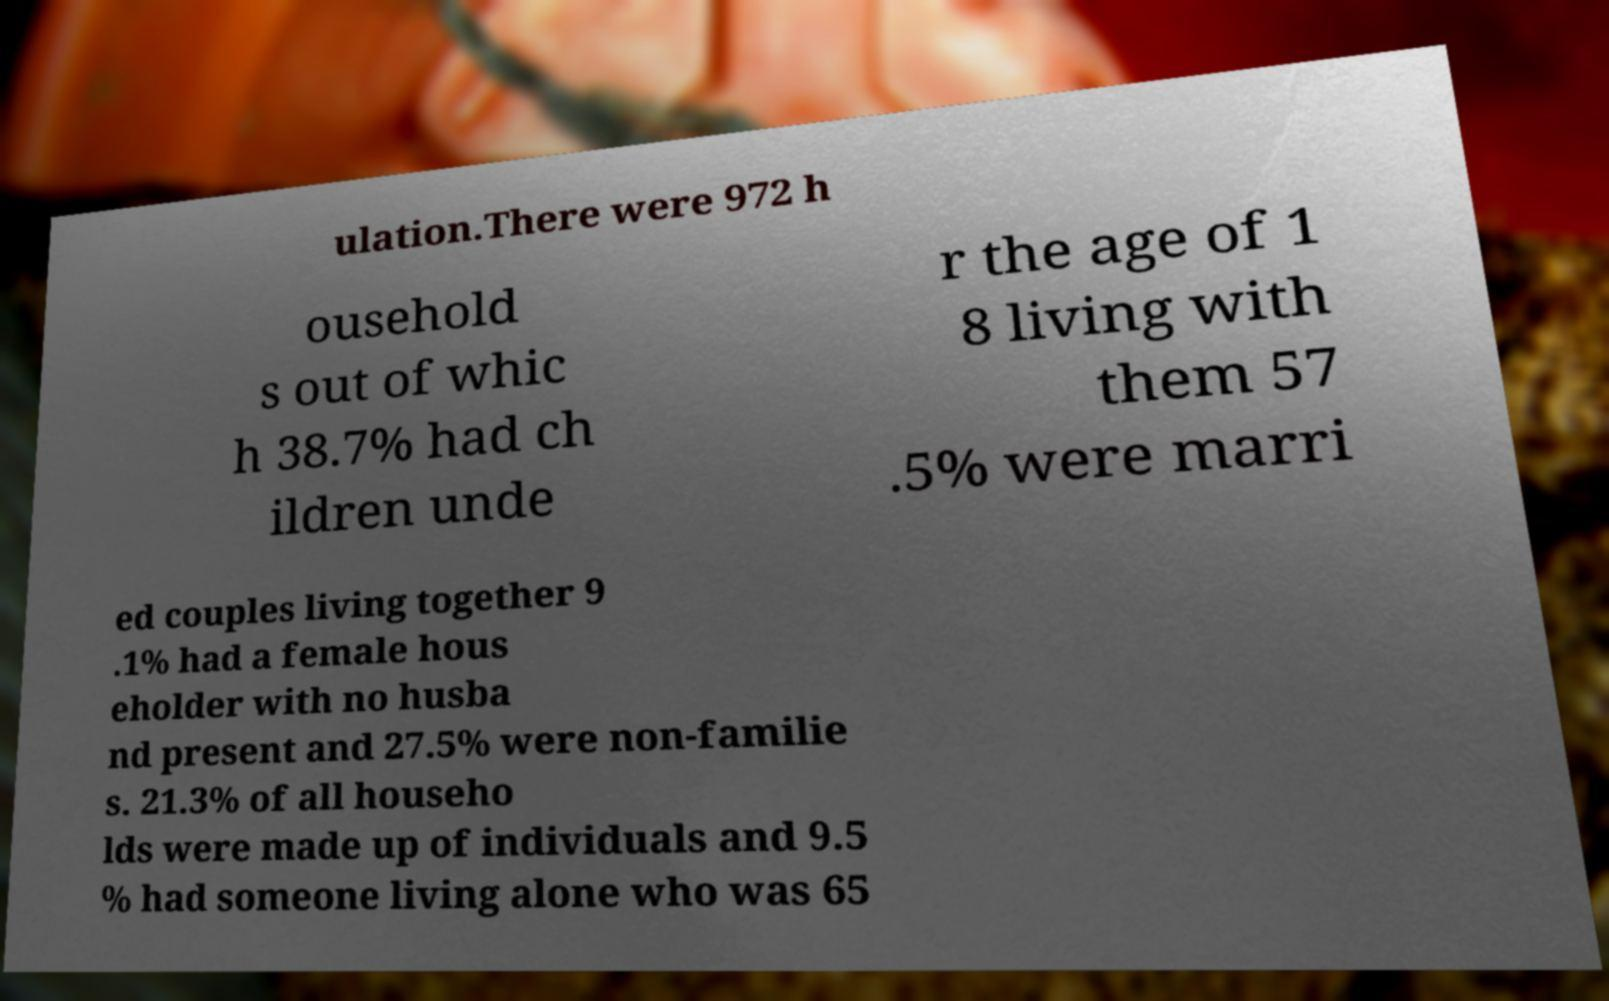Could you extract and type out the text from this image? ulation.There were 972 h ousehold s out of whic h 38.7% had ch ildren unde r the age of 1 8 living with them 57 .5% were marri ed couples living together 9 .1% had a female hous eholder with no husba nd present and 27.5% were non-familie s. 21.3% of all househo lds were made up of individuals and 9.5 % had someone living alone who was 65 